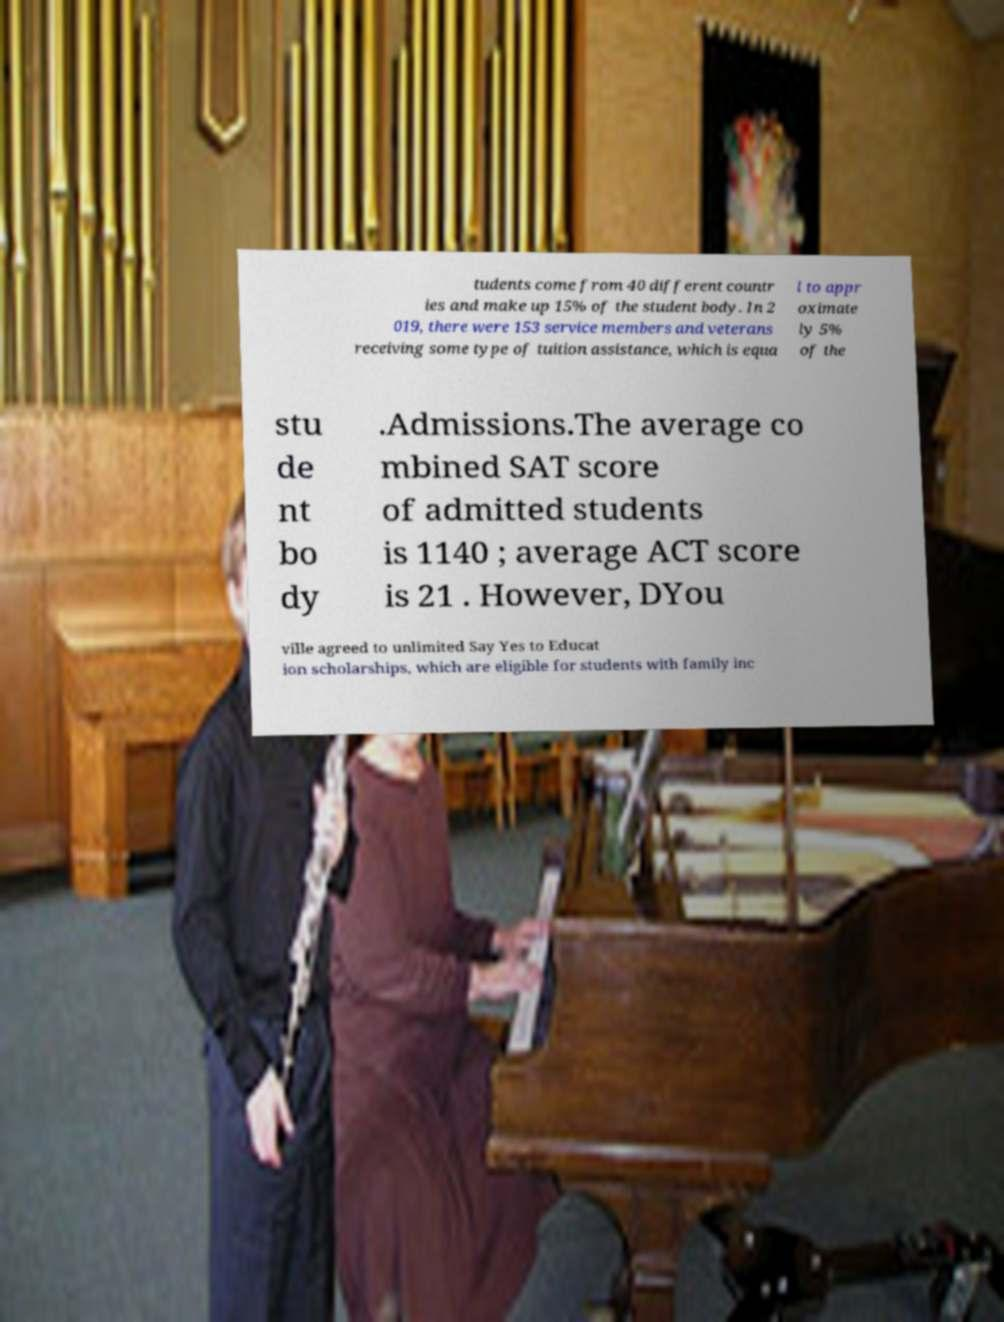Please identify and transcribe the text found in this image. tudents come from 40 different countr ies and make up 15% of the student body. In 2 019, there were 153 service members and veterans receiving some type of tuition assistance, which is equa l to appr oximate ly 5% of the stu de nt bo dy .Admissions.The average co mbined SAT score of admitted students is 1140 ; average ACT score is 21 . However, DYou ville agreed to unlimited Say Yes to Educat ion scholarships, which are eligible for students with family inc 